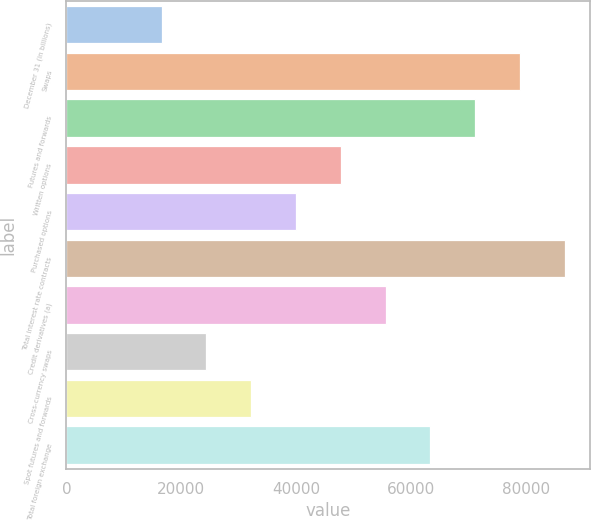Convert chart. <chart><loc_0><loc_0><loc_500><loc_500><bar_chart><fcel>December 31 (in billions)<fcel>Swaps<fcel>Futures and forwards<fcel>Written options<fcel>Purchased options<fcel>Total interest rate contracts<fcel>Credit derivatives (a)<fcel>Cross-currency swaps<fcel>Spot futures and forwards<fcel>Total foreign exchange<nl><fcel>16558.6<fcel>78905<fcel>71111.7<fcel>47731.8<fcel>39938.5<fcel>86698.3<fcel>55525.1<fcel>24351.9<fcel>32145.2<fcel>63318.4<nl></chart> 